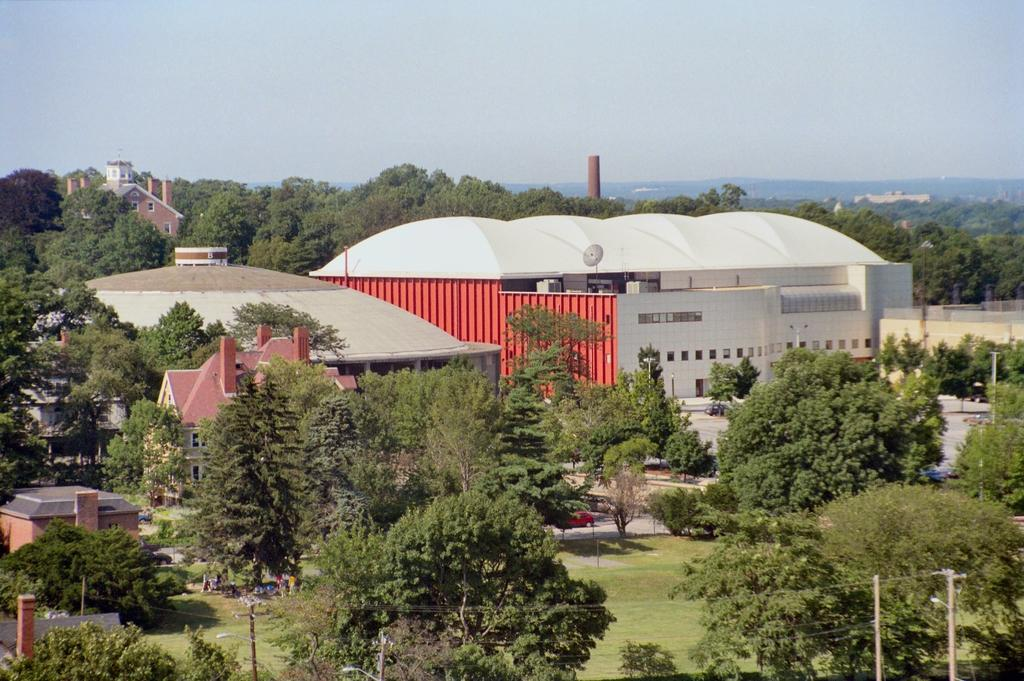What type of structure is present in the image? There is a building in the image. What surrounds the building? There are many trees around the building. What type of vegetation is at the bottom of the image? There is green grass at the bottom of the image. What is visible at the top of the image? The sky is visible at the top of the image. How many eggs are hidden in the branches of the trees in the image? There are no eggs visible in the image, as it features a building surrounded by trees and green grass. 